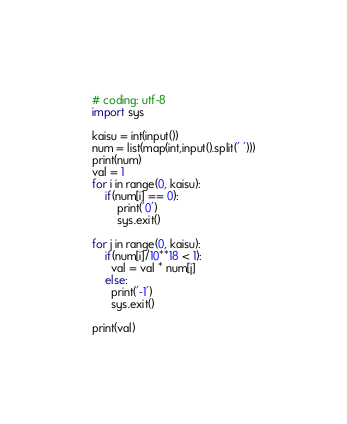Convert code to text. <code><loc_0><loc_0><loc_500><loc_500><_Python_># coding: utf-8
import sys

kaisu = int(input())
num = list(map(int,input().split(' ')))
print(num)
val = 1
for i in range(0, kaisu):
    if(num[i] == 0):
        print('0')
        sys.exit()

for j in range(0, kaisu):
  	if(num[i]/10**18 < 1):
      val = val * num[j]
    else:
      print('-1')
      sys.exit()

print(val)</code> 